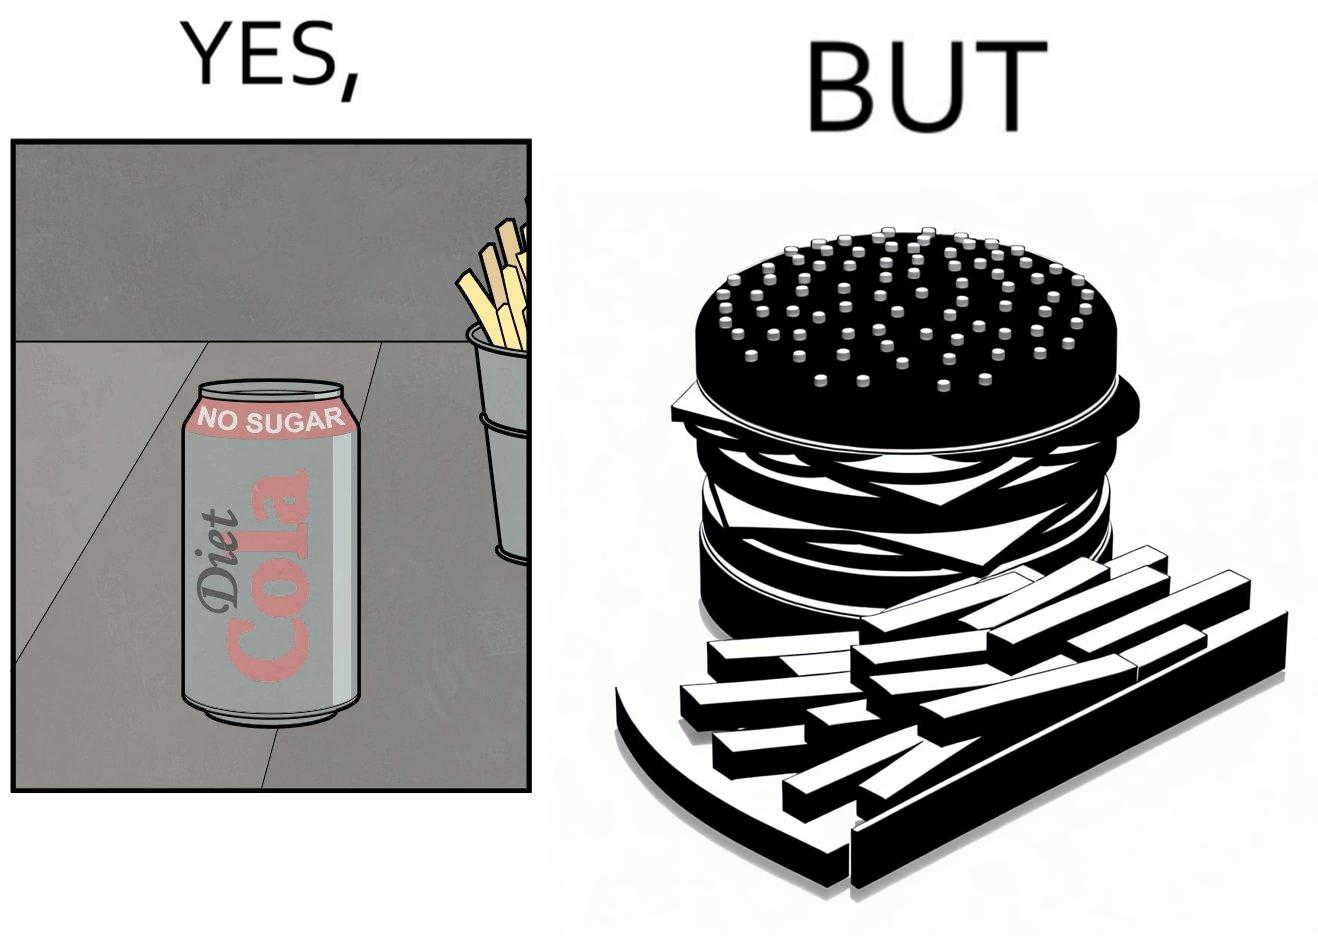Describe what you see in this image. The image is ironic, because on one hand the person is consuming diet cola suggesting low on sugar as per label meaning the person is health-conscious but on the other hand the same one is having huge size burger with french fries which suggests the person to be health-ignorant 